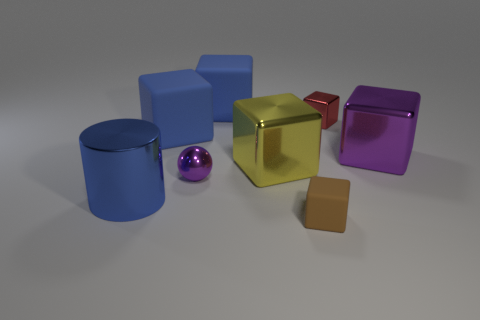Subtract 2 cubes. How many cubes are left? 4 Subtract all red blocks. How many blocks are left? 5 Subtract all tiny metallic cubes. How many cubes are left? 5 Subtract all brown cubes. Subtract all red cylinders. How many cubes are left? 5 Add 1 small brown cubes. How many objects exist? 9 Subtract all spheres. How many objects are left? 7 Subtract 1 yellow blocks. How many objects are left? 7 Subtract all yellow metallic cubes. Subtract all big green matte spheres. How many objects are left? 7 Add 4 big objects. How many big objects are left? 9 Add 7 purple rubber cylinders. How many purple rubber cylinders exist? 7 